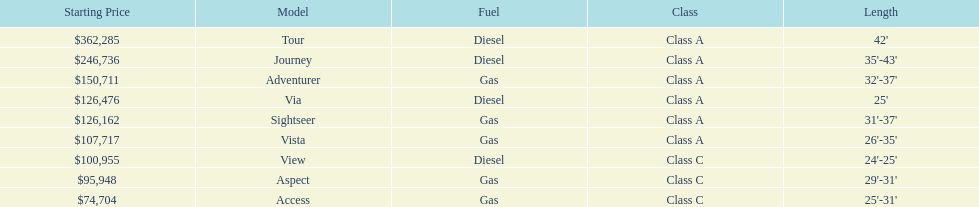What is the price of bot the via and tour models combined? $488,761. 